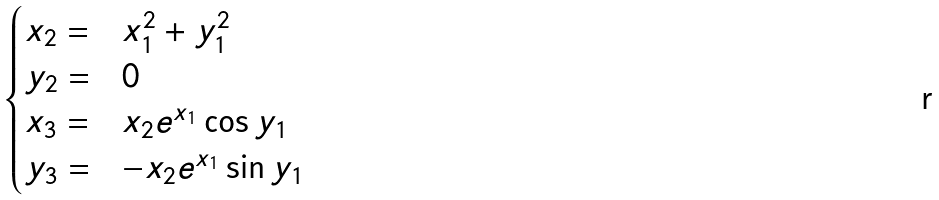<formula> <loc_0><loc_0><loc_500><loc_500>\begin{cases} x _ { 2 } = & x _ { 1 } ^ { 2 } + y _ { 1 } ^ { 2 } \\ y _ { 2 } = & 0 \\ x _ { 3 } = & x _ { 2 } e ^ { x _ { 1 } } \cos { y _ { 1 } } \\ y _ { 3 } = & - x _ { 2 } e ^ { x _ { 1 } } \sin { y _ { 1 } } \end{cases}</formula> 